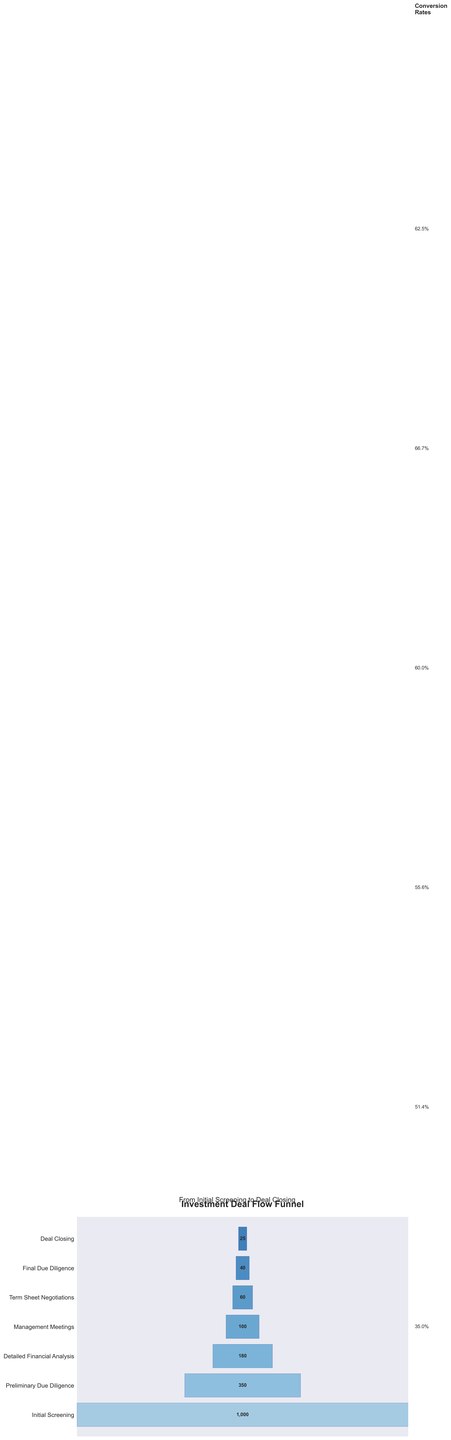What's the title of the chart? The title is displayed at the top of the figure and can be easily identified by a quick look.
Answer: Investment Deal Flow Funnel At which stage does the highest drop-off of deals occur? To find the highest drop-off, compare the difference in the number of deals between consecutive stages. The largest difference is between Initial Screening (1000 deals) and Preliminary Due Diligence (350 deals), a drop of 650 deals.
Answer: Initial Screening to Preliminary Due Diligence What percentage of deals make it from Initial Screening to Final Due Diligence? The number of deals that make it from Initial Screening to Final Due Diligence is 40 out of the initial 1000. The percentage is calculated by (40/1000) * 100.
Answer: 4% How many more deals make it from Detailed Financial Analysis to Term Sheet Negotiations compared to Final Due Diligence to Deal Closing? Calculate the differences: (180 - 60) for Detailed Financial Analysis to Term Sheet Negotiations, and (40 - 25) for Final Due Diligence to Deal Closing. Then compare: 120 vs. 15.
Answer: 105 What is the average number of deals across all stages? Sum all the deals and divide by the number of stages: (1000 + 350 + 180 + 100 + 60 + 40 + 25) / 7.
Answer: 250.7 Which stage has the fewest deals? Identify the smallest number from the data provided. The smallest number of deals is 25 at Deal Closing.
Answer: Deal Closing What is the conversion rate from Management Meetings to Term Sheet Negotiations? The conversion rate is found by (Number of deals at Term Sheet Negotiations / Number of deals at Management Meetings) * 100, so (60/100) * 100.
Answer: 60% Which two consecutive stages have the closest number of deals? Compare the differences between consecutive stages and find the smallest difference. The smallest difference is between Final Due Diligence (40 deals) and Deal Closing (25 deals), which is 15 deals.
Answer: Final Due Diligence and Deal Closing How many stages involve fewer than 100 deals? Count the stages where the number of deals is less than 100. These stages are Term Sheet Negotiations, Final Due Diligence, and Deal Closing.
Answer: 3 